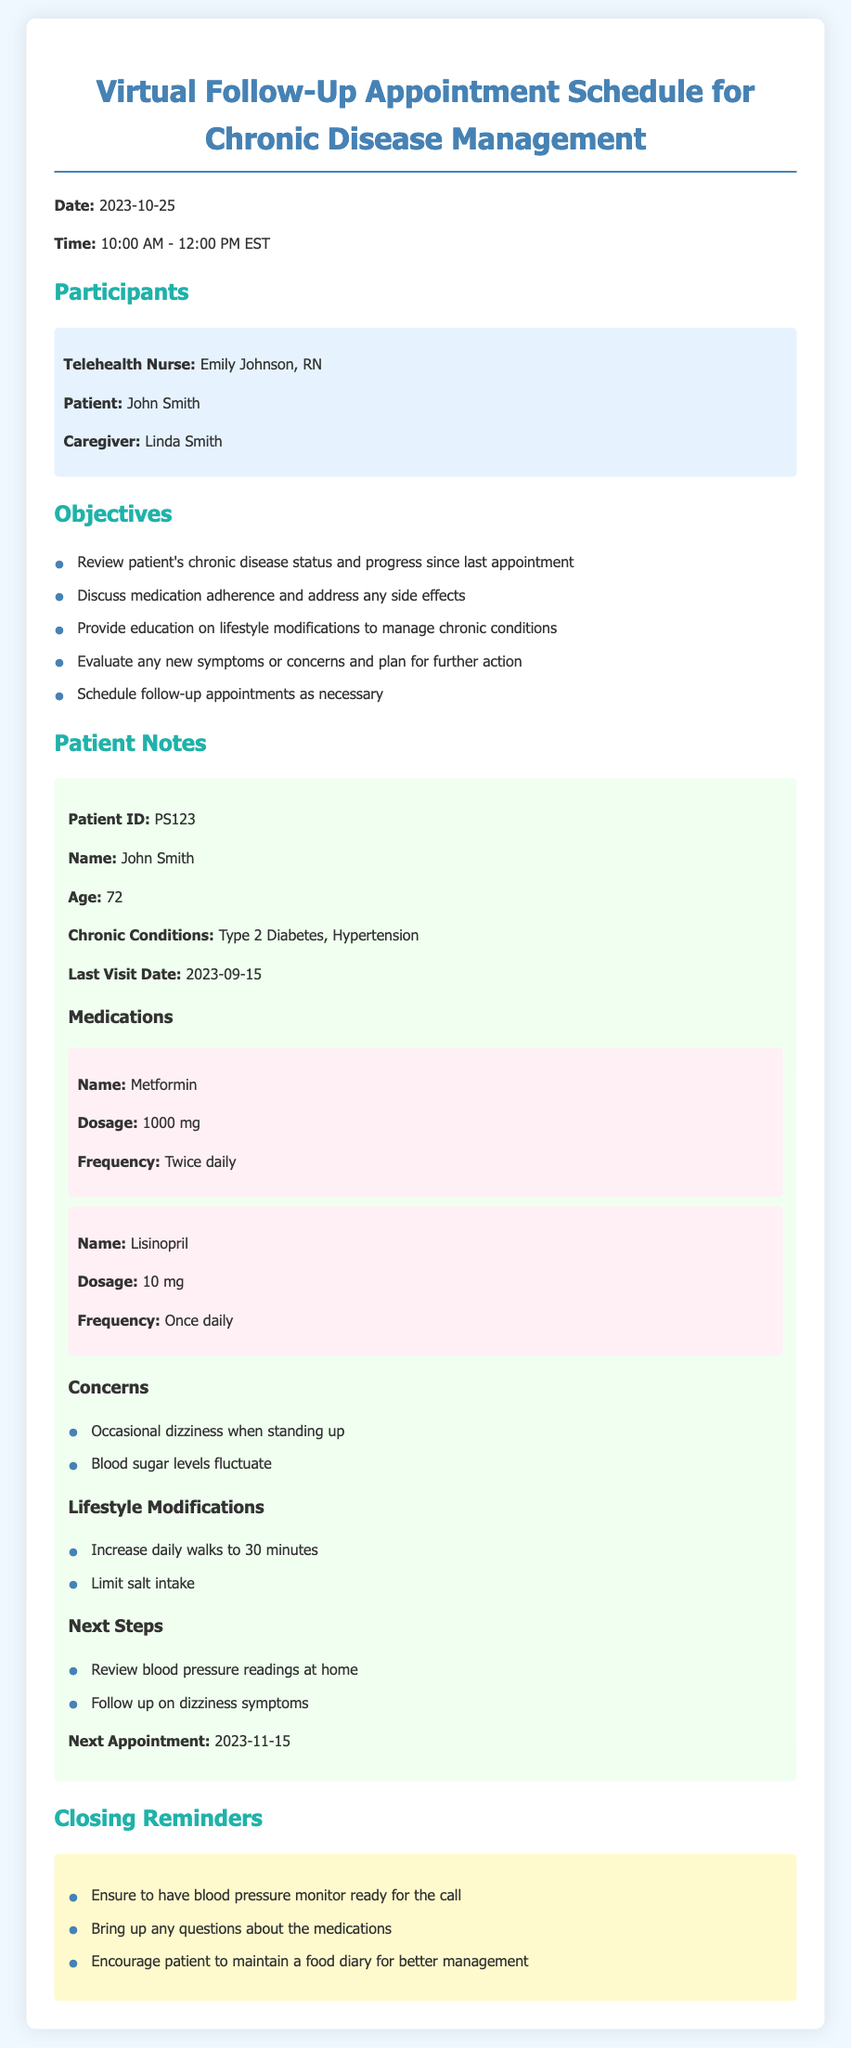What is the date of the appointment? The date of the appointment is specifically listed in the document as 2023-10-25.
Answer: 2023-10-25 Who is the telehealth nurse for this appointment? The document identifies Emily Johnson as the telehealth nurse involved in the appointment.
Answer: Emily Johnson What chronic conditions does the patient have? The document lists the patient's chronic conditions, which are Type 2 Diabetes and Hypertension.
Answer: Type 2 Diabetes, Hypertension What is the patient's next appointment date? The document states that the next appointment for the patient is on 2023-11-15.
Answer: 2023-11-15 What is the frequency of the medication Metformin? The document specifies that Metformin is to be taken twice daily.
Answer: Twice daily What concerns does the patient have? The patient has mentioned two main concerns in the document, which are occasional dizziness when standing up and fluctuating blood sugar levels.
Answer: Occasional dizziness, fluctuating blood sugar levels What lifestyle modification is recommended regarding physical activity? The document recommends increasing daily walks to 30 minutes as a key lifestyle modification.
Answer: Increase daily walks to 30 minutes What should the patient prepare before the appointment? The document clearly states that the patient should ensure to have a blood pressure monitor ready for the call.
Answer: Blood pressure monitor What type of document is this agenda related to? The provided document is specifically related to a follow-up appointment for chronic disease management in a telehealth context.
Answer: Virtual Follow-Up Appointment Schedule 